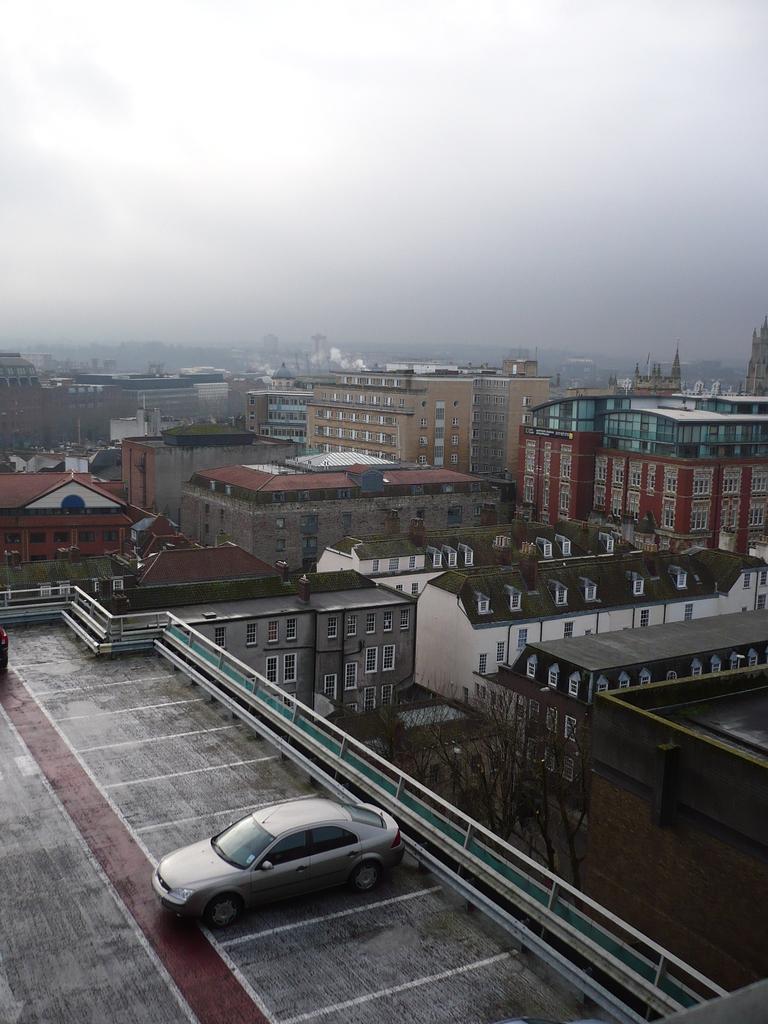How would you summarize this image in a sentence or two? In this image at the bottom there are some buildings houses trees and some windows, in the background there are some mountains. At the bottom there is one terrace, on the terrace there is one car and on the top of the image there is sky. 